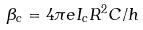Convert formula to latex. <formula><loc_0><loc_0><loc_500><loc_500>\beta _ { c } = 4 \pi e I _ { c } R ^ { 2 } C / h</formula> 